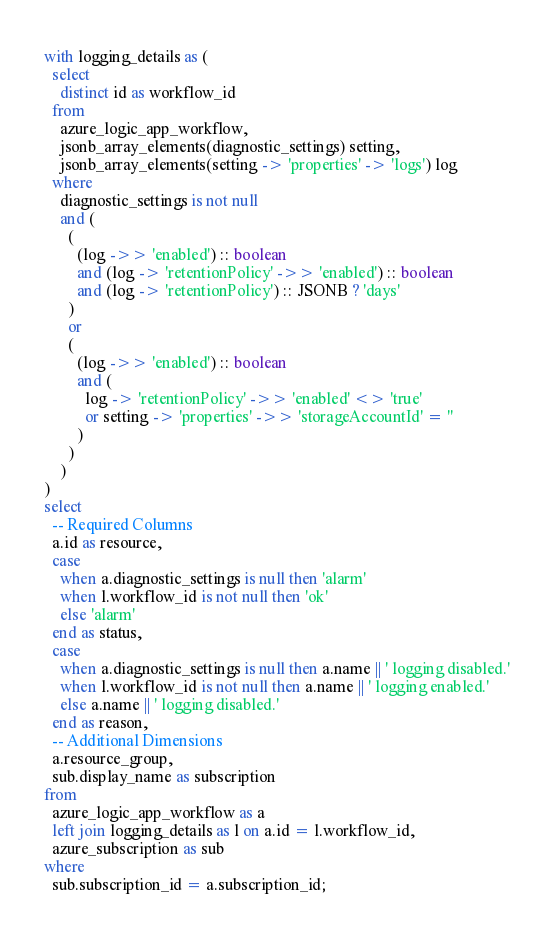<code> <loc_0><loc_0><loc_500><loc_500><_SQL_>with logging_details as (
  select
    distinct id as workflow_id
  from
    azure_logic_app_workflow,
    jsonb_array_elements(diagnostic_settings) setting,
    jsonb_array_elements(setting -> 'properties' -> 'logs') log
  where
    diagnostic_settings is not null
    and (
      (
        (log ->> 'enabled') :: boolean
        and (log -> 'retentionPolicy' ->> 'enabled') :: boolean
        and (log -> 'retentionPolicy') :: JSONB ? 'days'
      )
      or
      (
        (log ->> 'enabled') :: boolean
        and (
          log -> 'retentionPolicy' ->> 'enabled' <> 'true'
          or setting -> 'properties' ->> 'storageAccountId' = ''
        )
      )
    )
)
select
  -- Required Columns
  a.id as resource,
  case
    when a.diagnostic_settings is null then 'alarm'
    when l.workflow_id is not null then 'ok'
    else 'alarm'
  end as status,
  case
    when a.diagnostic_settings is null then a.name || ' logging disabled.'
    when l.workflow_id is not null then a.name || ' logging enabled.'
    else a.name || ' logging disabled.'
  end as reason,
  -- Additional Dimensions
  a.resource_group,
  sub.display_name as subscription
from
  azure_logic_app_workflow as a
  left join logging_details as l on a.id = l.workflow_id,
  azure_subscription as sub
where
  sub.subscription_id = a.subscription_id;</code> 